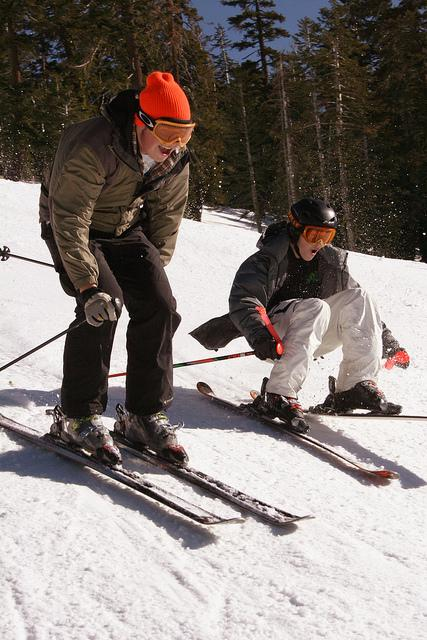What is this sport name? Please explain your reasoning. skiing. As indicated by the skis on their feet. 